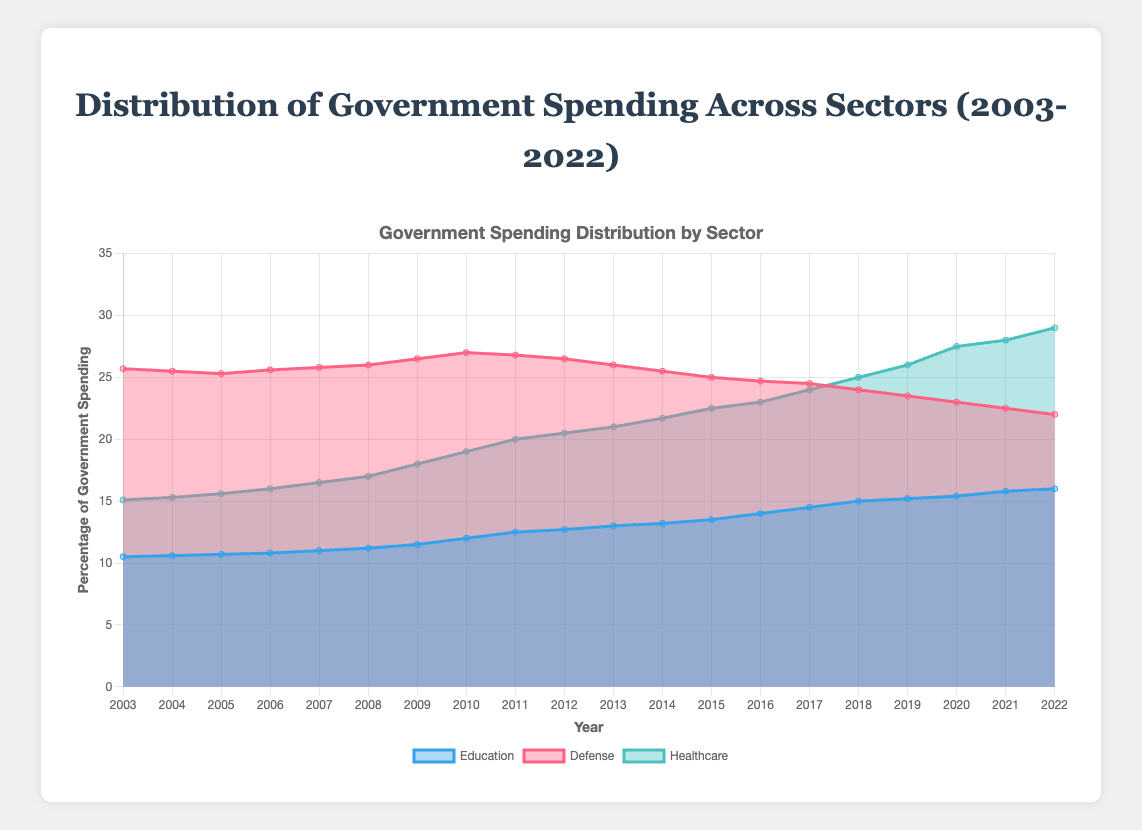What's the title of the chart? The title of the chart can be found at the top, usually in a larger font size for easy identification.
Answer: Distribution of Government Spending Across Sectors (2003-2022) Which sector had the highest spending in 2010? Look at the data for 2010 and compare the values across sectors.
Answer: Defense How many years of data are displayed on the chart? Count the number of years listed on the x-axis.
Answer: 20 What is the trend in spending for Education over the period? Observe the shape and direction of the area for Education on the chart over time.
Answer: Increasing By how much did Healthcare spending increase from 2003 to 2022? Subtract the spending value in 2003 from the spending value in 2022 for Healthcare.
Answer: 13.9 How does the change in Defense spending from 2003 to 2022 compare with the change in Healthcare spending over the same period? Calculate the difference in spending for both sectors between 2003 and 2022, then compare these differences.
Answer: Defense decreased by 3.7; Healthcare increased by 13.9 What feature of the chart allows you to distinguish between different sectors? Identify the visual elements used to differentiate sectors, such as colors and labels.
Answer: Colors and labels Which sector showed the most variability in spending over the 20 years? Evaluate which sector has the largest range or most fluctuations in the area on the chart.
Answer: Healthcare In which year did Education spending first surpass 15%? Find the first year where the Education spending value exceeds 15%.
Answer: 2018 What's the average spending percentage of Healthcare between 2010 and 2020? Add up the Healthcare spending values from 2010 to 2020 and divide by the number of years (11).
Answer: 22.41 